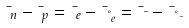Convert formula to latex. <formula><loc_0><loc_0><loc_500><loc_500>\mu _ { n } - \mu _ { p } = \mu _ { e } - \mu _ { \nu _ { e } } = \mu _ { \mu } - \mu _ { \nu _ { \mu } }</formula> 